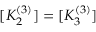Convert formula to latex. <formula><loc_0><loc_0><loc_500><loc_500>[ K _ { 2 } ^ { ( 3 ) } ] = [ K _ { 3 } ^ { ( 3 ) } ]</formula> 